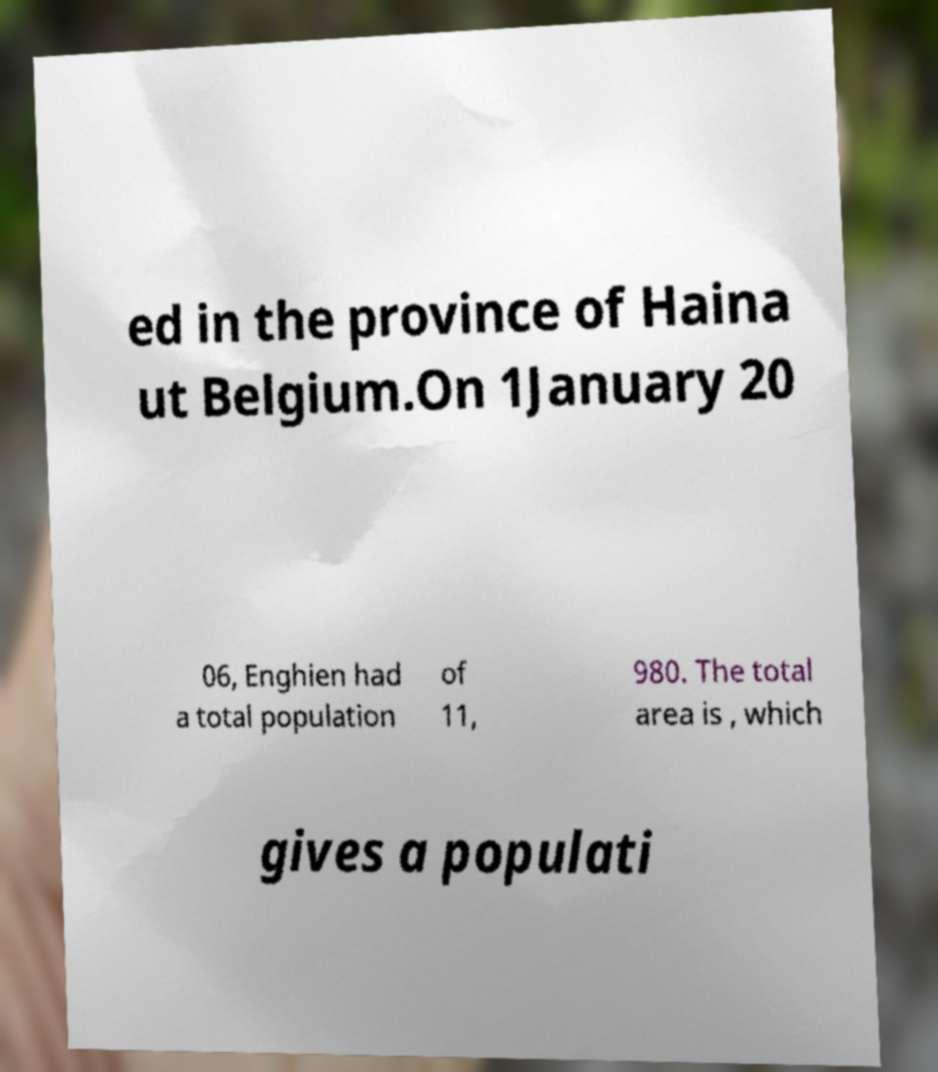For documentation purposes, I need the text within this image transcribed. Could you provide that? ed in the province of Haina ut Belgium.On 1January 20 06, Enghien had a total population of 11, 980. The total area is , which gives a populati 